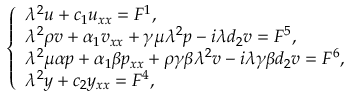<formula> <loc_0><loc_0><loc_500><loc_500>\left \{ \begin{array} { l } { { \lambda } ^ { 2 } u + c _ { 1 } u _ { x x } = F ^ { 1 } , } \\ { { \lambda } ^ { 2 } \rho v + \alpha _ { 1 } v _ { x x } + \gamma \mu { \lambda } ^ { 2 } p - i { \lambda } d _ { 2 } v = F ^ { 5 } , } \\ { { \lambda } ^ { 2 } \mu \alpha p + \alpha _ { 1 } \beta p _ { x x } + \rho \gamma \beta { \lambda } ^ { 2 } v - i { \lambda } \gamma \beta d _ { 2 } v = F ^ { 6 } , } \\ { { \lambda } ^ { 2 } y + c _ { 2 } y _ { x x } = F ^ { 4 } , } \end{array}</formula> 